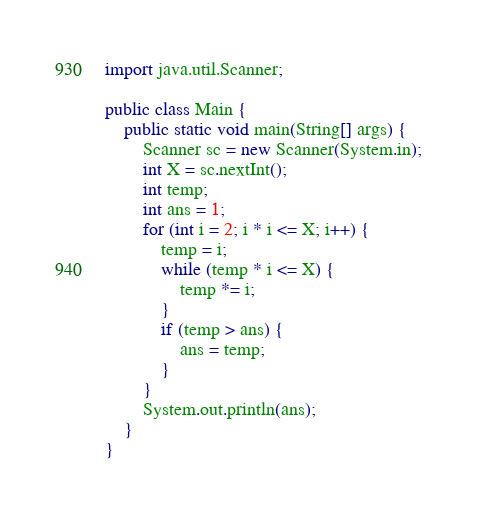<code> <loc_0><loc_0><loc_500><loc_500><_Java_>import java.util.Scanner;

public class Main {
	public static void main(String[] args) {
		Scanner sc = new Scanner(System.in);
		int X = sc.nextInt();
		int temp;
		int ans = 1;
		for (int i = 2; i * i <= X; i++) {
			temp = i;
			while (temp * i <= X) {
				temp *= i;
			}
			if (temp > ans) {
				ans = temp;
			}
		}
		System.out.println(ans);
	}
}
</code> 